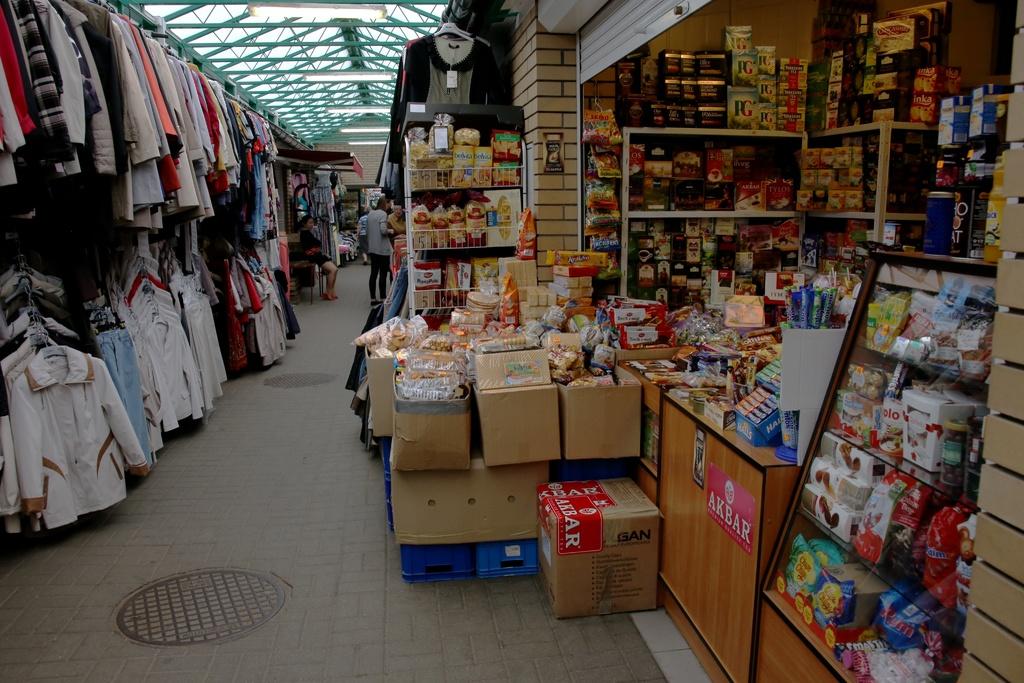What is written on the red poster on the bottom?
Give a very brief answer. Akbar. Which brands appear in the store?
Ensure brevity in your answer.  Akbar. 